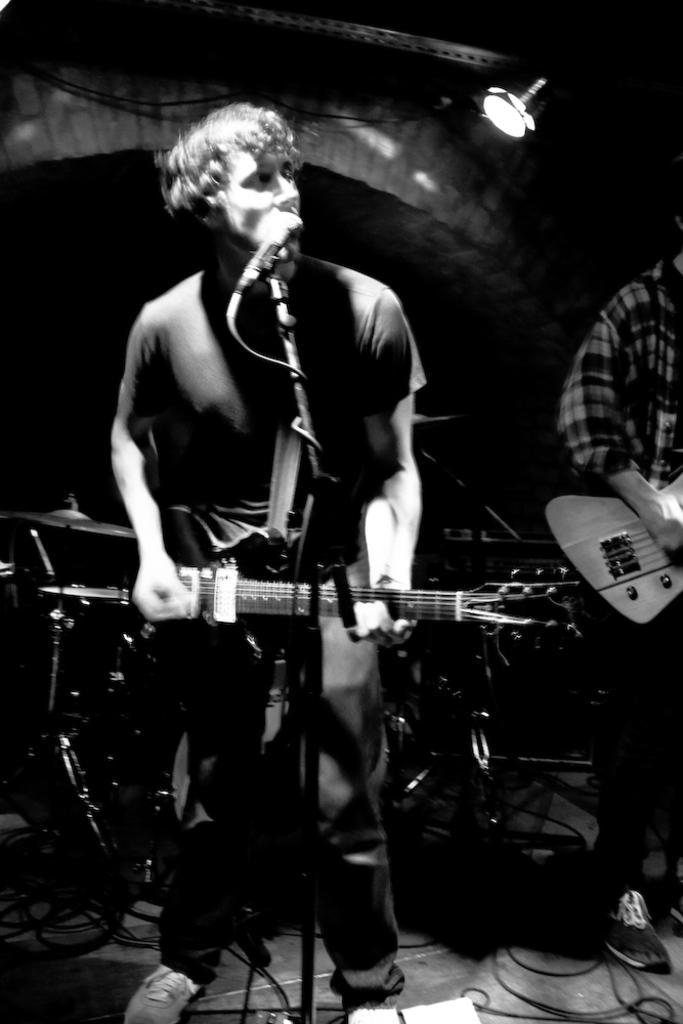Please provide a concise description of this image. In this picture there is a person standing and playing a guitar and singing 